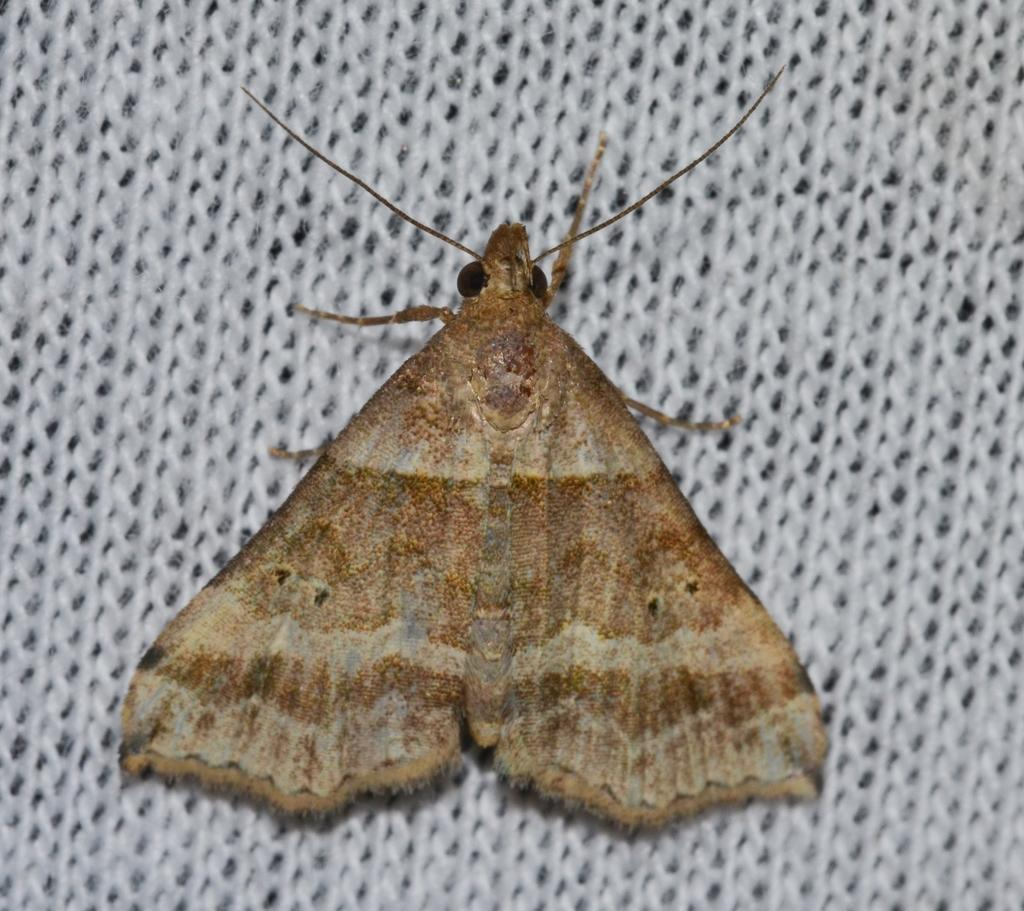What type of insect is present in the image? There is a moth in the image. What color is the object on which the moth is resting? The moth is on a white color object. What time is displayed on the watch in the image? There is no watch present in the image; it only features a moth on a white color object. 